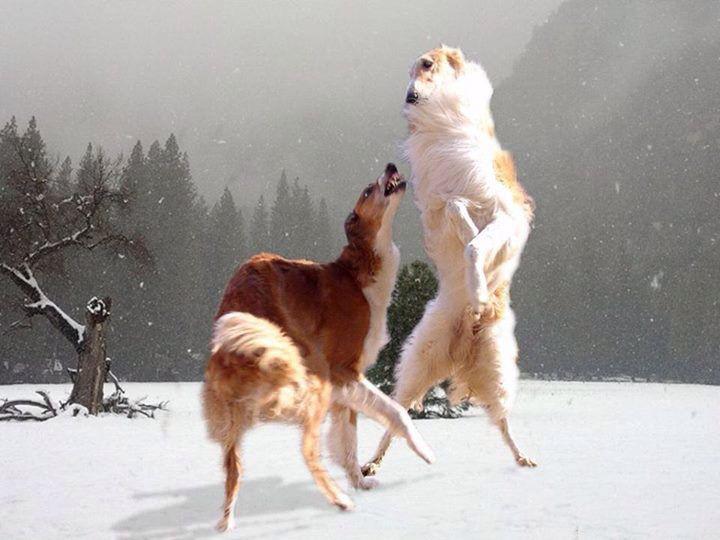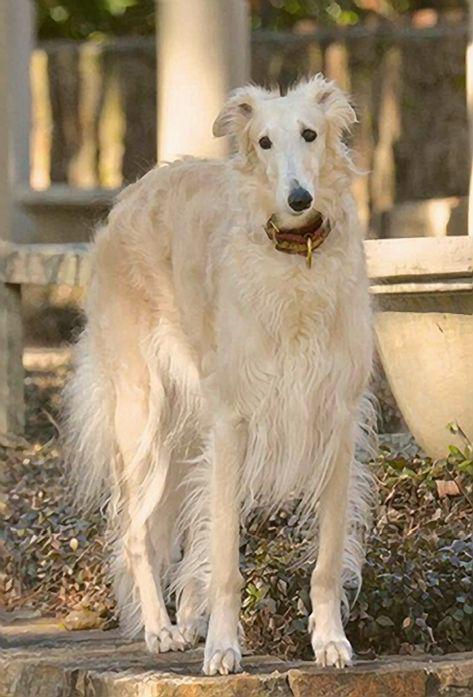The first image is the image on the left, the second image is the image on the right. Examine the images to the left and right. Is the description "The dog in the image on the right is carrying something in its mouth." accurate? Answer yes or no. Yes. The first image is the image on the left, the second image is the image on the right. For the images displayed, is the sentence "A dog that is mostly orange and a dog that is mostly white are together in a field covered with snow." factually correct? Answer yes or no. Yes. 